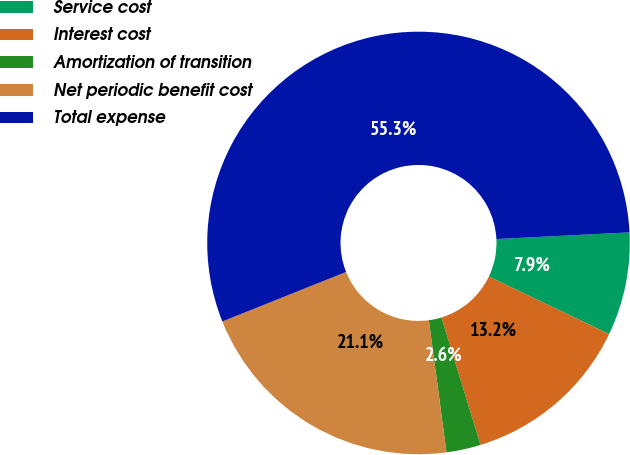Convert chart. <chart><loc_0><loc_0><loc_500><loc_500><pie_chart><fcel>Service cost<fcel>Interest cost<fcel>Amortization of transition<fcel>Net periodic benefit cost<fcel>Total expense<nl><fcel>7.89%<fcel>13.16%<fcel>2.63%<fcel>21.05%<fcel>55.26%<nl></chart> 